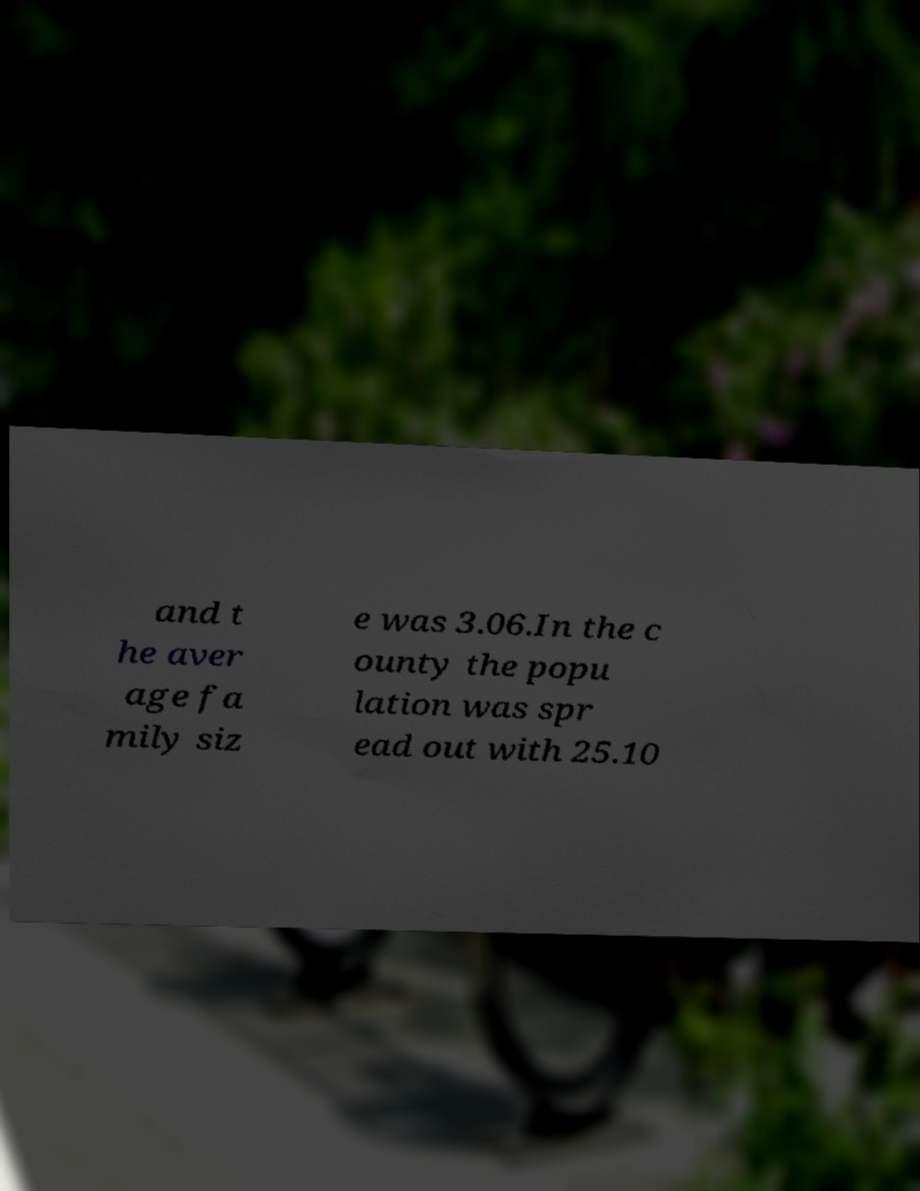Can you read and provide the text displayed in the image?This photo seems to have some interesting text. Can you extract and type it out for me? and t he aver age fa mily siz e was 3.06.In the c ounty the popu lation was spr ead out with 25.10 